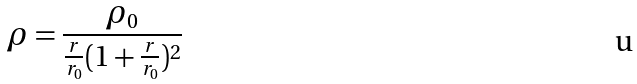Convert formula to latex. <formula><loc_0><loc_0><loc_500><loc_500>\rho = \frac { \rho _ { 0 } } { \frac { r } { r _ { 0 } } ( 1 + \frac { r } { r _ { 0 } } ) ^ { 2 } }</formula> 